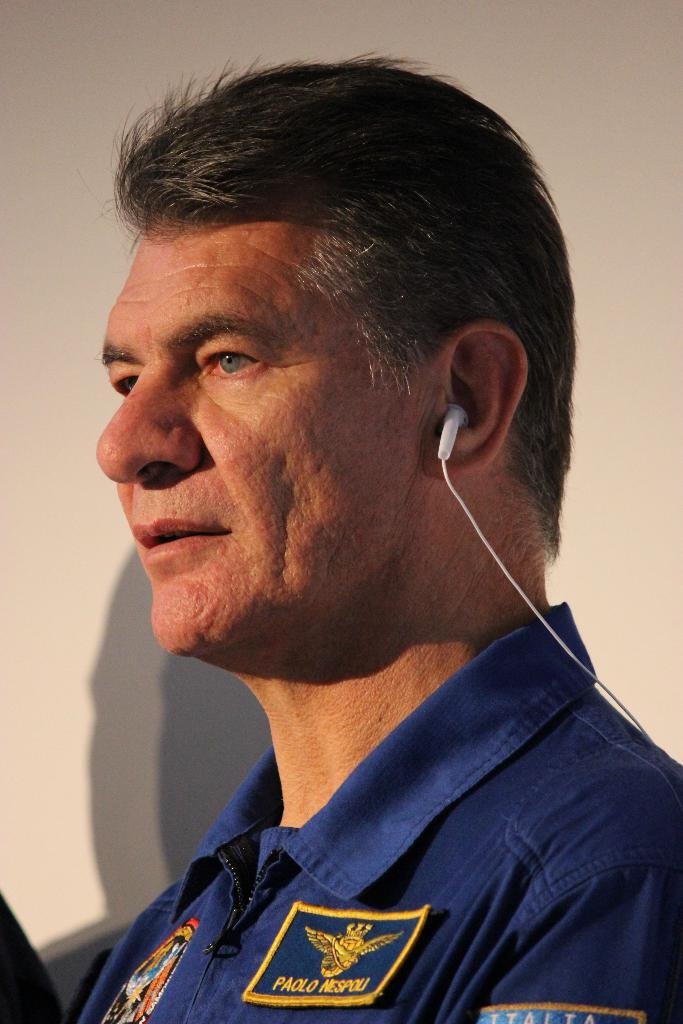What is present in the image? There is a person in the image. What is the person wearing? The person is wearing a blue dress. What color is the background of the image? The background of the image is cream-colored. How many kittens are playing with the toothpaste in the image? There are no kittens or toothpaste present in the image. What type of berry can be seen in the person's hand in the image? There is no berry present in the person's hand or anywhere else in the image. 